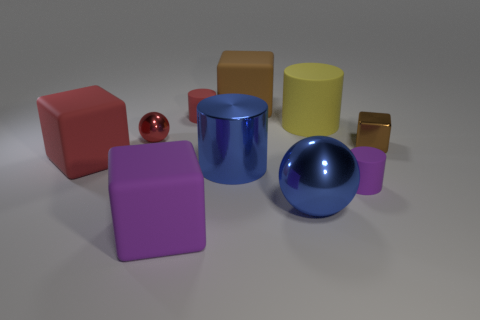Is the color of the big metal ball the same as the metallic cylinder? Yes, the big metal ball and the metallic cylinder share the same hue of blue. They both exhibit a shiny finish that reflects the environment, implying a similar material and surface treatment that enhances their visual connection through color and texture. 